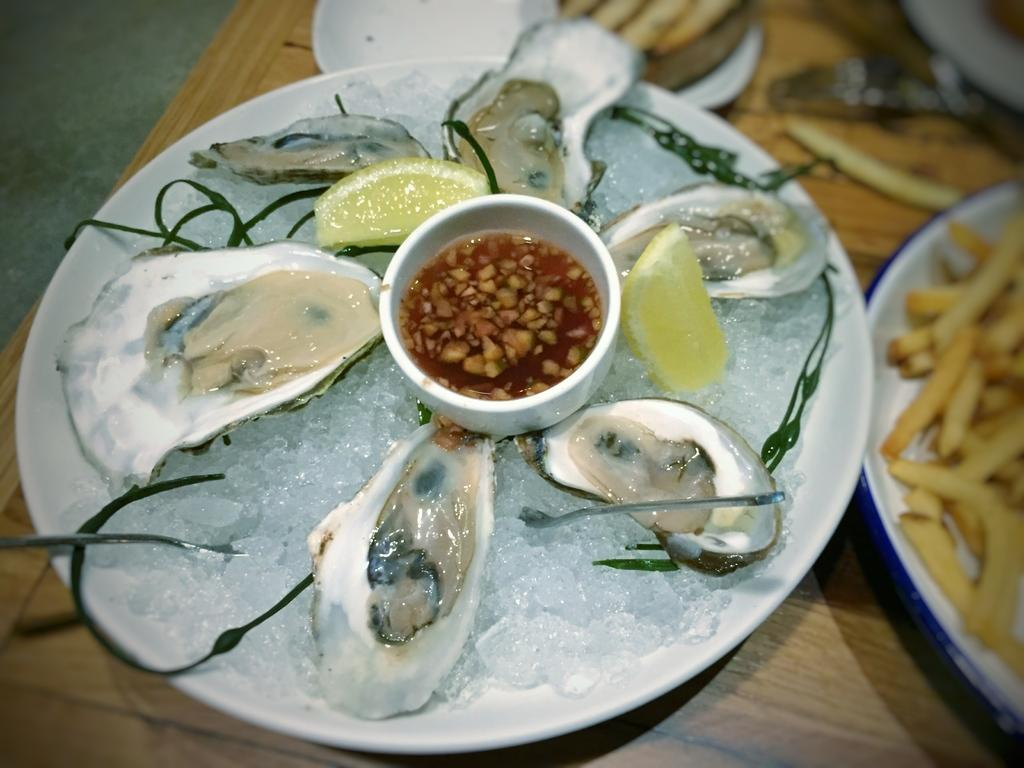What objects are on the table in the image? There are plates on the table in the image. What type of food is on one of the plates? There are french fries in one plate. What is in the other plate on the table? There is food in another plate. Can you tell me how many kitties are playing with a bulb in the image? There are no kitties or bulbs present in the image; it only features plates with food. 